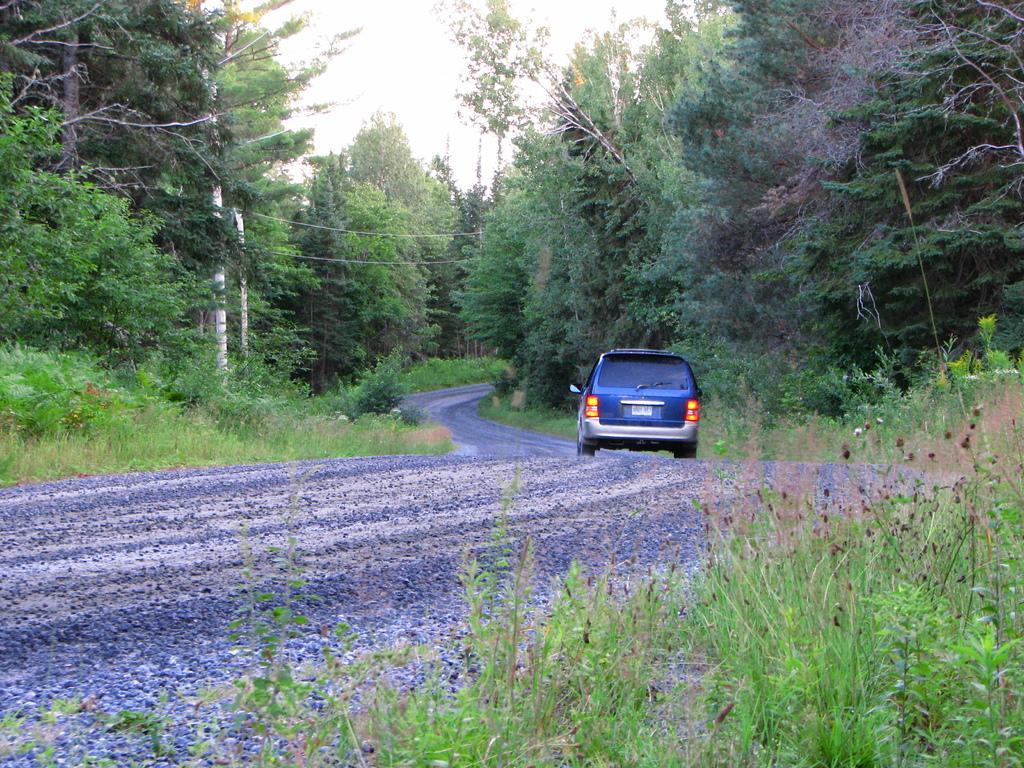Please provide a concise description of this image. This is an outside view. In the middle of the image there is a car on the road. On both sides of the road, I can see the grass and trees. On the left side there are two poles. At the top of the image I can see the sky. 